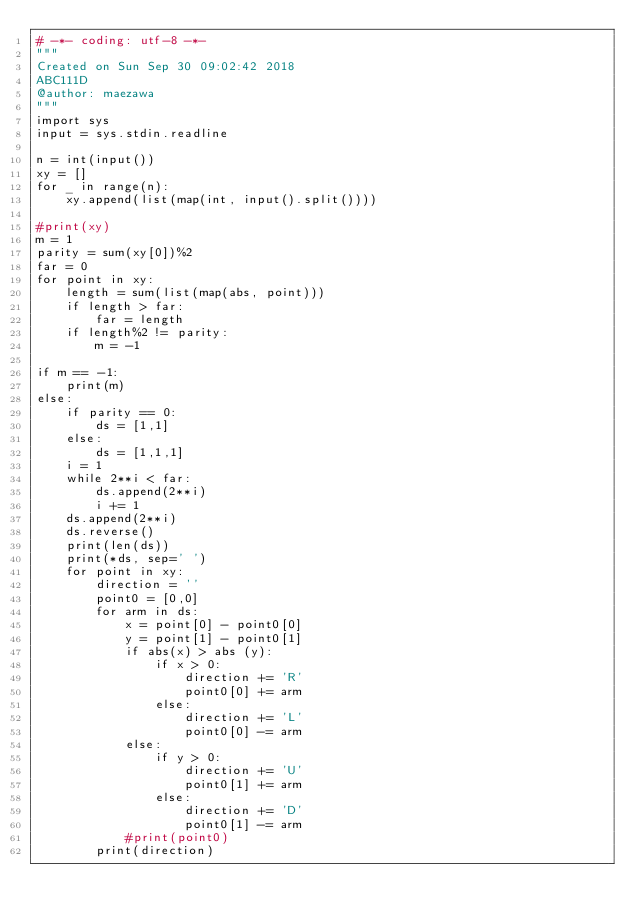Convert code to text. <code><loc_0><loc_0><loc_500><loc_500><_Python_># -*- coding: utf-8 -*-
"""
Created on Sun Sep 30 09:02:42 2018
ABC111D
@author: maezawa
"""
import sys
input = sys.stdin.readline

n = int(input())
xy = []
for _ in range(n):
    xy.append(list(map(int, input().split())))
    
#print(xy)
m = 1
parity = sum(xy[0])%2
far = 0
for point in xy:
    length = sum(list(map(abs, point)))
    if length > far:
        far = length
    if length%2 != parity:
        m = -1

if m == -1:
    print(m)
else:
    if parity == 0:
        ds = [1,1]
    else:
        ds = [1,1,1]
    i = 1
    while 2**i < far:
        ds.append(2**i)
        i += 1
    ds.append(2**i)
    ds.reverse()
    print(len(ds))
    print(*ds, sep=' ')
    for point in xy:
        direction = ''
        point0 = [0,0]
        for arm in ds:
            x = point[0] - point0[0]
            y = point[1] - point0[1]
            if abs(x) > abs (y):
                if x > 0:
                    direction += 'R'
                    point0[0] += arm
                else:
                    direction += 'L'
                    point0[0] -= arm
            else:
                if y > 0:
                    direction += 'U'
                    point0[1] += arm
                else:
                    direction += 'D'
                    point0[1] -= arm
            #print(point0)
        print(direction)
                    
            
    
        
        </code> 